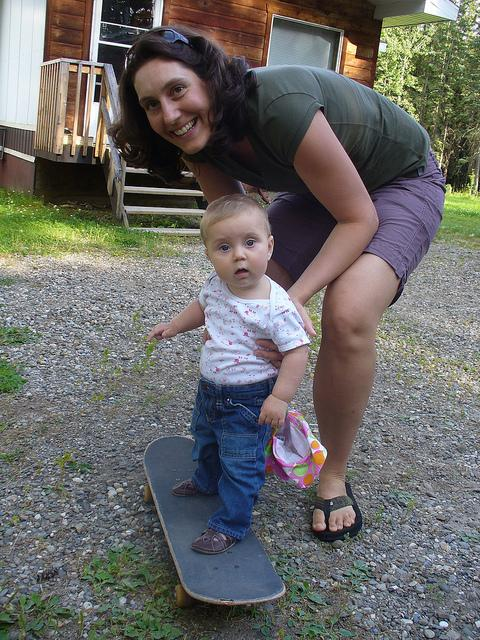What brand of sandals is the woman wearing? Please explain your reasoning. reef. The logo is on the sandals. 